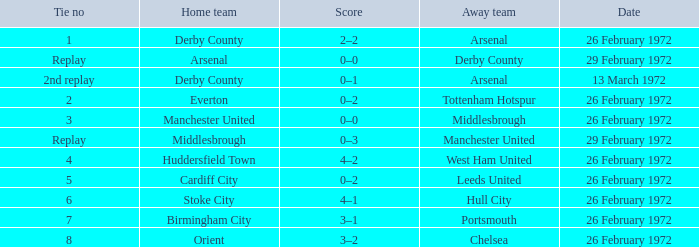Which everton tie is being referred to? 2.0. 